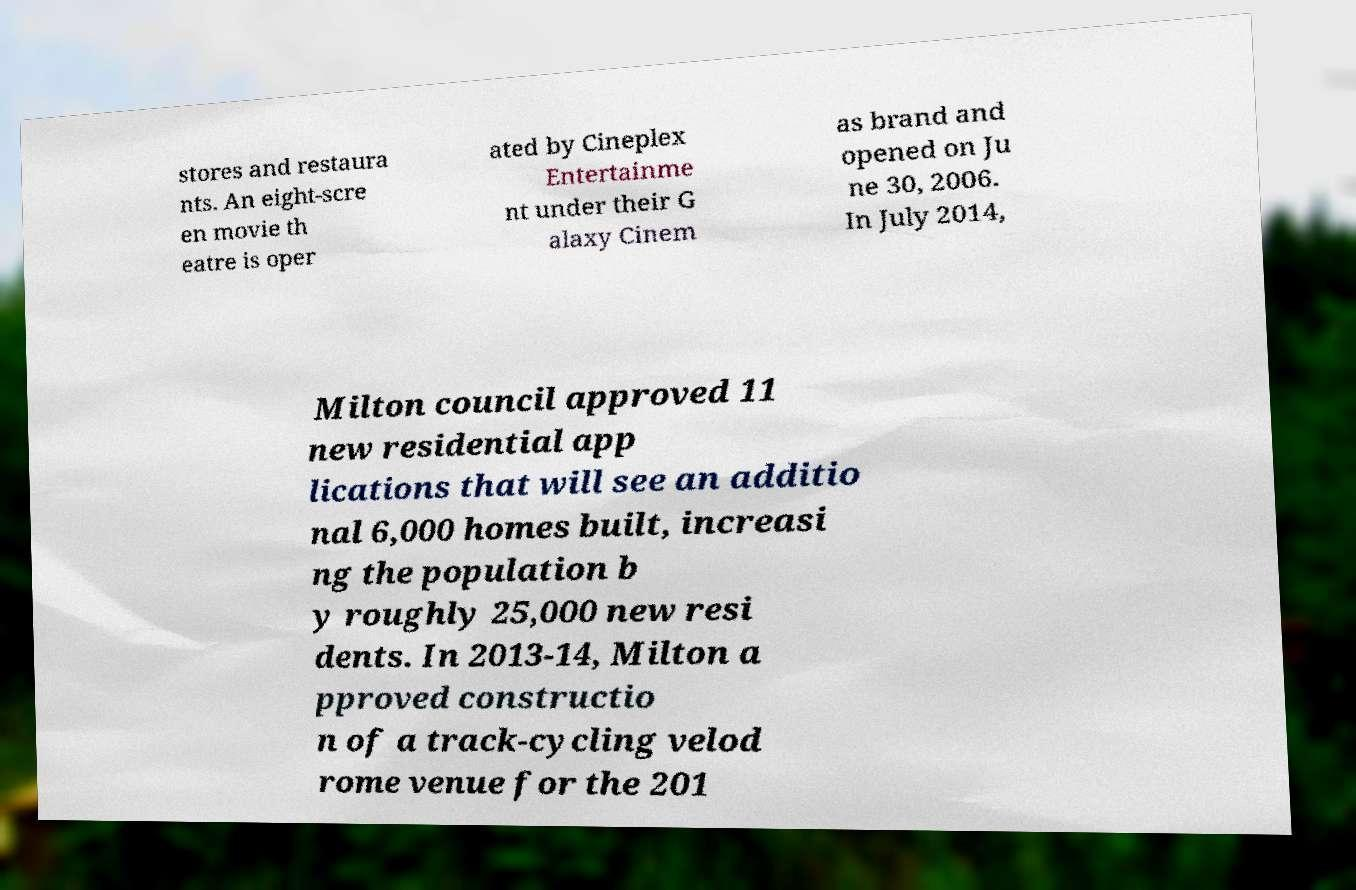Could you extract and type out the text from this image? stores and restaura nts. An eight-scre en movie th eatre is oper ated by Cineplex Entertainme nt under their G alaxy Cinem as brand and opened on Ju ne 30, 2006. In July 2014, Milton council approved 11 new residential app lications that will see an additio nal 6,000 homes built, increasi ng the population b y roughly 25,000 new resi dents. In 2013-14, Milton a pproved constructio n of a track-cycling velod rome venue for the 201 